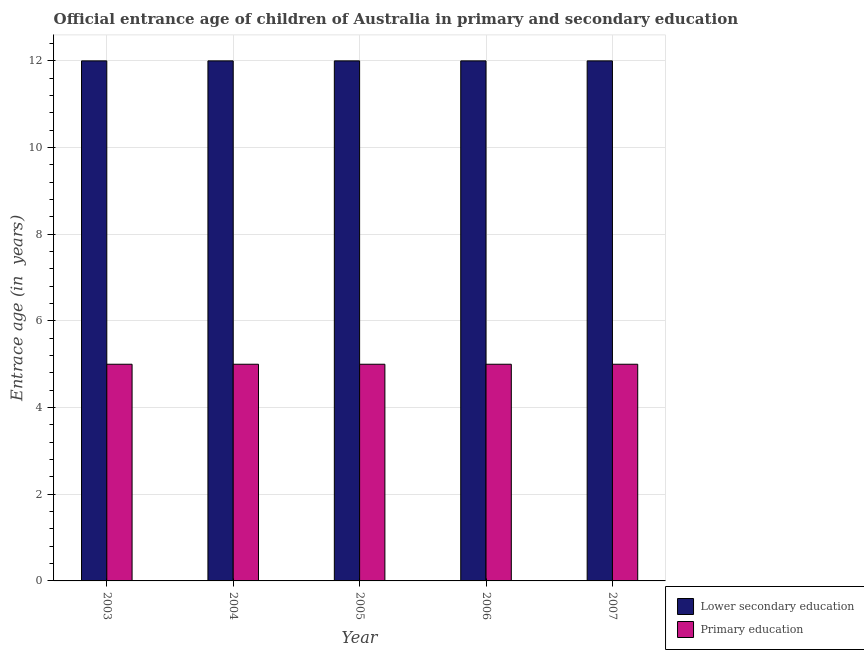How many different coloured bars are there?
Provide a succinct answer. 2. Are the number of bars per tick equal to the number of legend labels?
Keep it short and to the point. Yes. Are the number of bars on each tick of the X-axis equal?
Provide a succinct answer. Yes. How many bars are there on the 1st tick from the right?
Offer a terse response. 2. What is the label of the 5th group of bars from the left?
Offer a very short reply. 2007. In how many cases, is the number of bars for a given year not equal to the number of legend labels?
Offer a very short reply. 0. What is the entrance age of chiildren in primary education in 2006?
Your response must be concise. 5. Across all years, what is the maximum entrance age of children in lower secondary education?
Your response must be concise. 12. Across all years, what is the minimum entrance age of children in lower secondary education?
Ensure brevity in your answer.  12. What is the total entrance age of chiildren in primary education in the graph?
Offer a very short reply. 25. What is the difference between the entrance age of children in lower secondary education in 2005 and the entrance age of chiildren in primary education in 2003?
Your answer should be compact. 0. What is the average entrance age of children in lower secondary education per year?
Ensure brevity in your answer.  12. In how many years, is the entrance age of children in lower secondary education greater than 10.4 years?
Give a very brief answer. 5. What is the ratio of the entrance age of children in lower secondary education in 2004 to that in 2007?
Offer a very short reply. 1. What is the difference between the highest and the lowest entrance age of chiildren in primary education?
Offer a very short reply. 0. In how many years, is the entrance age of children in lower secondary education greater than the average entrance age of children in lower secondary education taken over all years?
Your answer should be very brief. 0. What does the 2nd bar from the right in 2005 represents?
Ensure brevity in your answer.  Lower secondary education. How many bars are there?
Your response must be concise. 10. What is the difference between two consecutive major ticks on the Y-axis?
Ensure brevity in your answer.  2. Does the graph contain any zero values?
Ensure brevity in your answer.  No. Where does the legend appear in the graph?
Make the answer very short. Bottom right. How many legend labels are there?
Provide a short and direct response. 2. How are the legend labels stacked?
Ensure brevity in your answer.  Vertical. What is the title of the graph?
Ensure brevity in your answer.  Official entrance age of children of Australia in primary and secondary education. What is the label or title of the X-axis?
Your answer should be very brief. Year. What is the label or title of the Y-axis?
Your response must be concise. Entrace age (in  years). What is the Entrace age (in  years) in Lower secondary education in 2004?
Give a very brief answer. 12. What is the Entrace age (in  years) in Primary education in 2004?
Your answer should be very brief. 5. What is the Entrace age (in  years) in Lower secondary education in 2005?
Provide a short and direct response. 12. What is the Entrace age (in  years) in Primary education in 2005?
Provide a succinct answer. 5. What is the Entrace age (in  years) of Primary education in 2006?
Your response must be concise. 5. What is the Entrace age (in  years) in Lower secondary education in 2007?
Give a very brief answer. 12. What is the Entrace age (in  years) in Primary education in 2007?
Ensure brevity in your answer.  5. Across all years, what is the minimum Entrace age (in  years) of Primary education?
Provide a short and direct response. 5. What is the total Entrace age (in  years) of Primary education in the graph?
Provide a short and direct response. 25. What is the difference between the Entrace age (in  years) in Primary education in 2003 and that in 2004?
Your response must be concise. 0. What is the difference between the Entrace age (in  years) in Primary education in 2003 and that in 2006?
Your answer should be very brief. 0. What is the difference between the Entrace age (in  years) in Lower secondary education in 2003 and that in 2007?
Ensure brevity in your answer.  0. What is the difference between the Entrace age (in  years) of Primary education in 2004 and that in 2005?
Give a very brief answer. 0. What is the difference between the Entrace age (in  years) in Primary education in 2004 and that in 2006?
Offer a terse response. 0. What is the difference between the Entrace age (in  years) in Primary education in 2004 and that in 2007?
Offer a terse response. 0. What is the difference between the Entrace age (in  years) of Lower secondary education in 2005 and that in 2006?
Ensure brevity in your answer.  0. What is the difference between the Entrace age (in  years) in Primary education in 2005 and that in 2006?
Offer a very short reply. 0. What is the difference between the Entrace age (in  years) of Lower secondary education in 2005 and that in 2007?
Provide a succinct answer. 0. What is the difference between the Entrace age (in  years) of Primary education in 2005 and that in 2007?
Provide a succinct answer. 0. What is the difference between the Entrace age (in  years) in Lower secondary education in 2003 and the Entrace age (in  years) in Primary education in 2006?
Offer a terse response. 7. What is the difference between the Entrace age (in  years) in Lower secondary education in 2004 and the Entrace age (in  years) in Primary education in 2005?
Your answer should be very brief. 7. What is the difference between the Entrace age (in  years) in Lower secondary education in 2005 and the Entrace age (in  years) in Primary education in 2006?
Your answer should be very brief. 7. What is the difference between the Entrace age (in  years) of Lower secondary education in 2005 and the Entrace age (in  years) of Primary education in 2007?
Your answer should be very brief. 7. What is the average Entrace age (in  years) in Primary education per year?
Offer a terse response. 5. In the year 2004, what is the difference between the Entrace age (in  years) in Lower secondary education and Entrace age (in  years) in Primary education?
Your answer should be very brief. 7. In the year 2006, what is the difference between the Entrace age (in  years) in Lower secondary education and Entrace age (in  years) in Primary education?
Give a very brief answer. 7. What is the ratio of the Entrace age (in  years) in Lower secondary education in 2003 to that in 2005?
Ensure brevity in your answer.  1. What is the ratio of the Entrace age (in  years) of Primary education in 2003 to that in 2005?
Provide a succinct answer. 1. What is the ratio of the Entrace age (in  years) in Lower secondary education in 2003 to that in 2006?
Provide a succinct answer. 1. What is the ratio of the Entrace age (in  years) of Primary education in 2003 to that in 2006?
Provide a short and direct response. 1. What is the ratio of the Entrace age (in  years) in Lower secondary education in 2003 to that in 2007?
Provide a succinct answer. 1. What is the ratio of the Entrace age (in  years) in Primary education in 2004 to that in 2006?
Offer a very short reply. 1. What is the ratio of the Entrace age (in  years) in Primary education in 2004 to that in 2007?
Your answer should be compact. 1. What is the ratio of the Entrace age (in  years) of Lower secondary education in 2005 to that in 2006?
Keep it short and to the point. 1. What is the ratio of the Entrace age (in  years) in Primary education in 2005 to that in 2007?
Provide a succinct answer. 1. What is the ratio of the Entrace age (in  years) in Primary education in 2006 to that in 2007?
Make the answer very short. 1. What is the difference between the highest and the second highest Entrace age (in  years) in Lower secondary education?
Ensure brevity in your answer.  0. What is the difference between the highest and the lowest Entrace age (in  years) in Lower secondary education?
Provide a short and direct response. 0. What is the difference between the highest and the lowest Entrace age (in  years) of Primary education?
Your answer should be very brief. 0. 